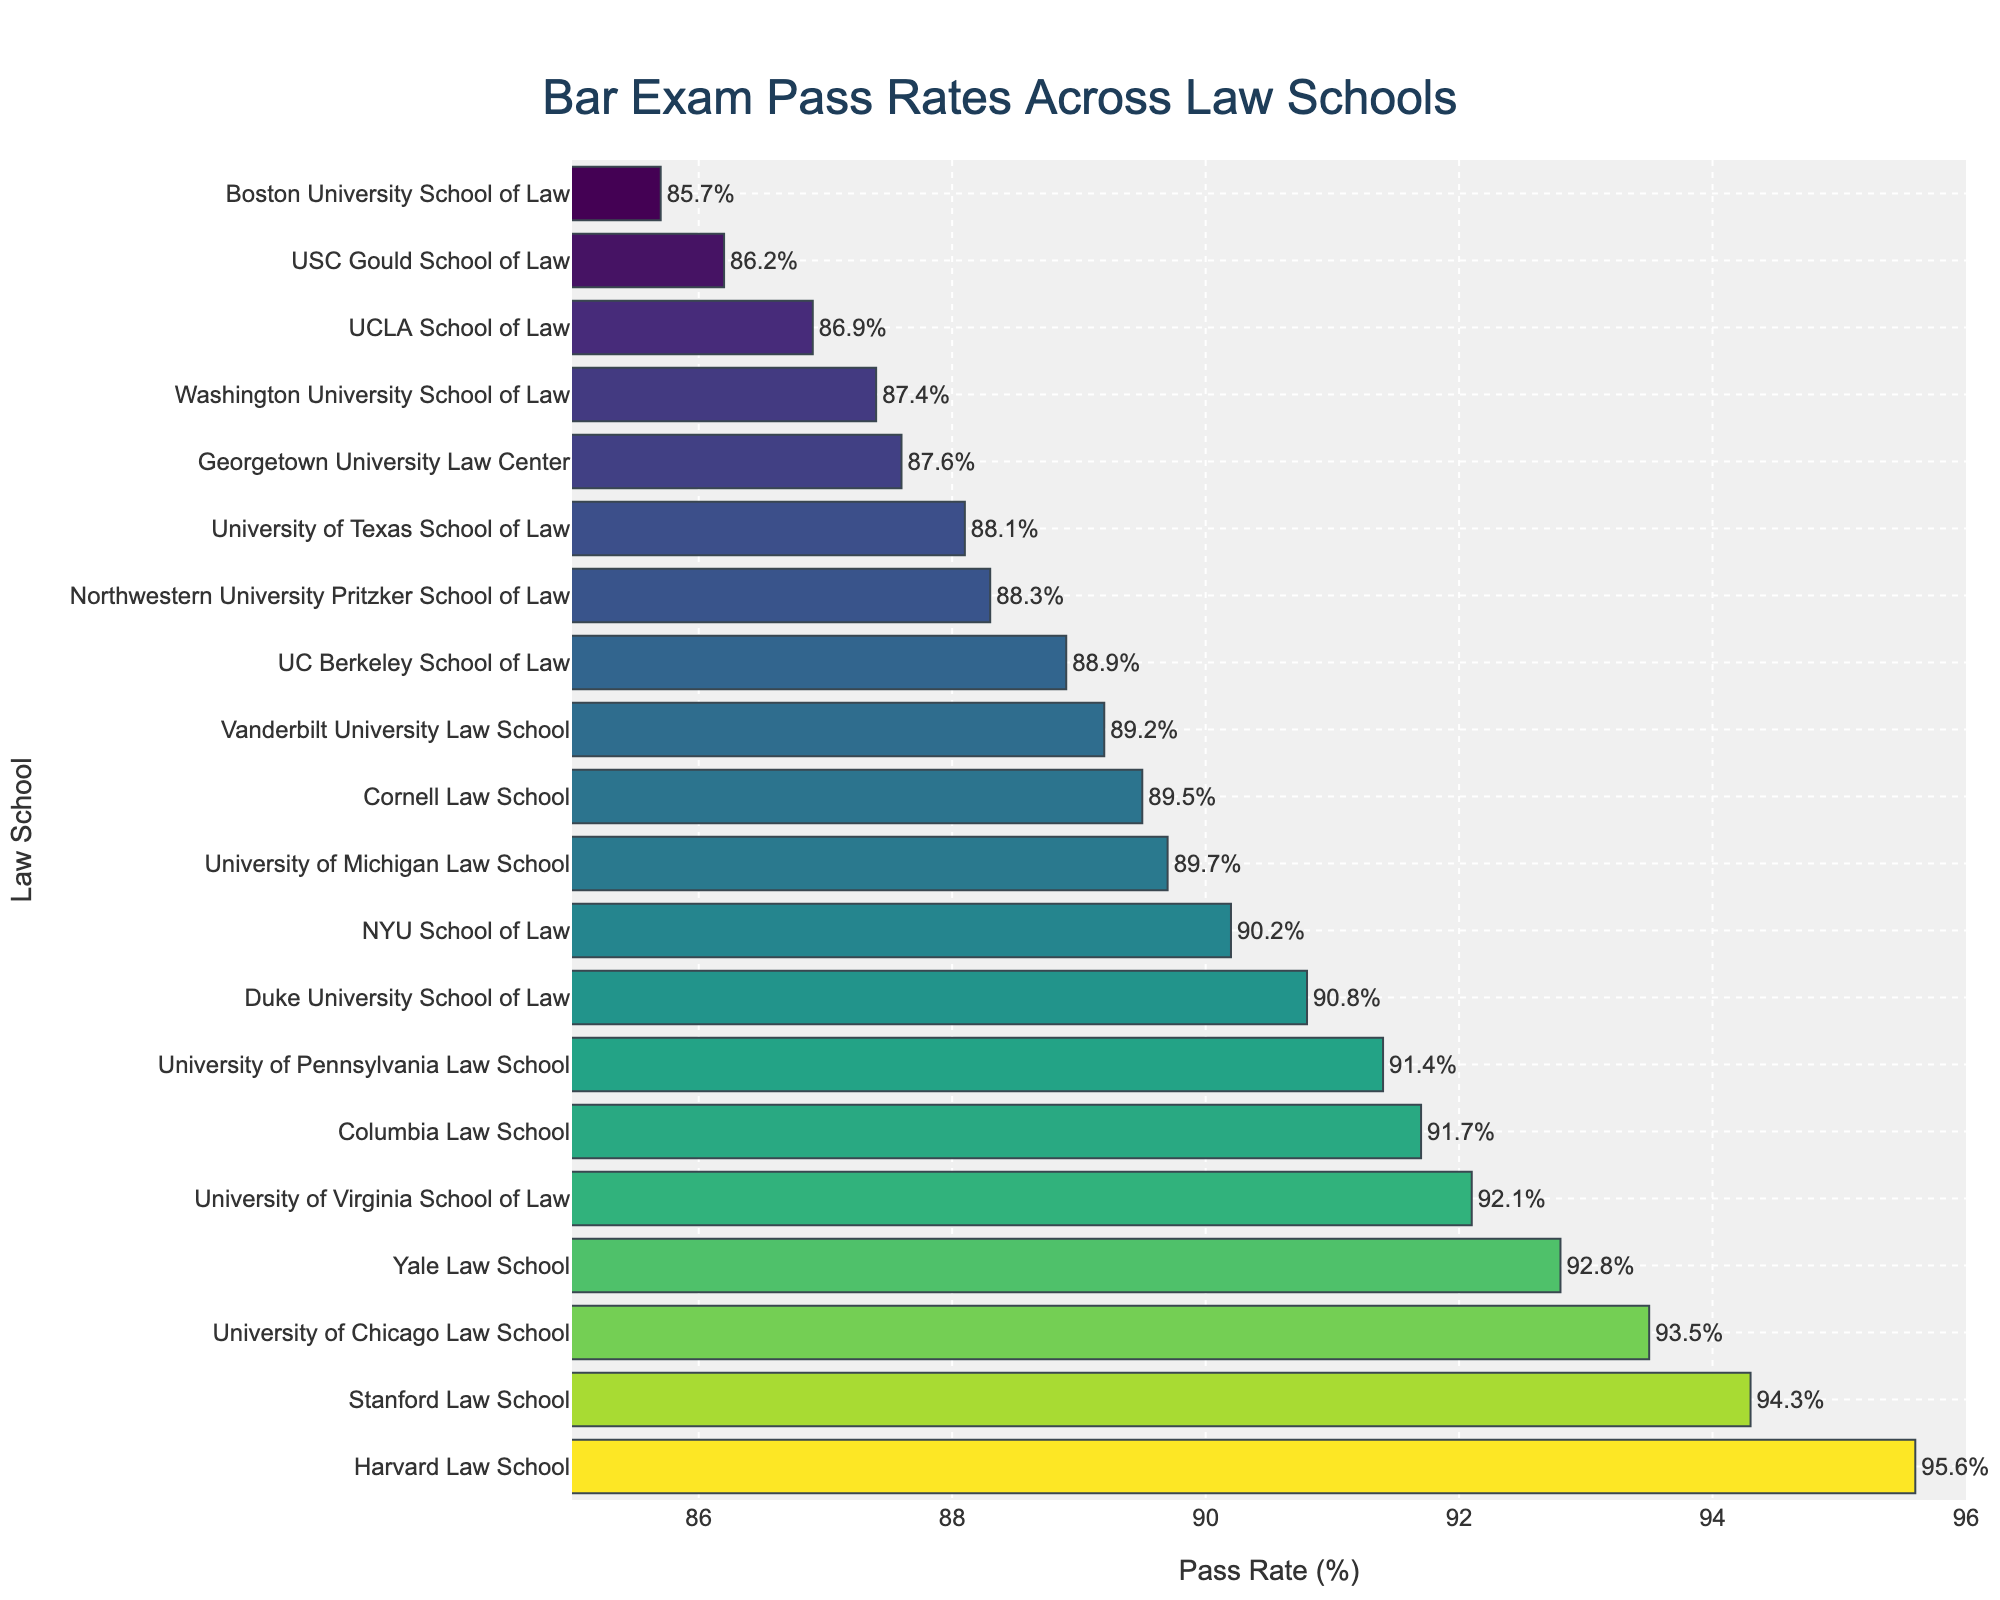Which law school has the highest Bar exam pass rate? By looking at the top position in the chart and the corresponding pass rate, which is the highest value, we see "Harvard Law School" with a pass rate of 95.6%.
Answer: Harvard Law School What is the difference in Bar exam pass rates between Harvard Law School and Columbia Law School? Find the pass rate for both Harvard Law School (95.6%) and Columbia Law School (91.7%), then subtract the latter from the former: 95.6% - 91.7% = 3.9%.
Answer: 3.9% What is the combined pass rate of the top three law schools? Identify the top three law schools by pass rates: Harvard Law School (95.6%), Stanford Law School (94.3%), and Yale Law School (92.8%). Add these rates: 95.6% + 94.3% + 92.8% = 282.7%.
Answer: 282.7% Which law schools have a pass rate less than 90%? Look for bars that are below the 90% line and identify their schools. These are UC Berkeley (88.9%), Northwestern University Pritzker (88.3%), Georgetown University (87.6%), UCLA (86.9%), USC Gould (86.2%), and Boston University School of Law (85.7%).
Answer: UC Berkeley, Northwestern University Pritzker, Georgetown University, UCLA, USC Gould, and Boston University What is the inverted ranking of the schools based on pass rates? Order the schools from the lowest pass rate to the highest by following the bar lengths from shortest to longest. Using that information, we can create the following list: Boston University (85.7%), USC Gould (86.2%), UCLA (86.9%), Georgetown (87.6%), Washington University (87.4%), Texas (88.1%), Northwestern (88.3%), UC Berkeley (88.9%), Vanderbilt (89.2%), Cornell (89.5%), Michigan (89.7%), NYU (90.2%), Duke (90.8%), Penn (91.4%), Columbia (91.7%), Virginia (92.1%), Yale (92.8%), Chicago (93.5%), Stanford (94.3%), Harvard (95.6%).
Answer: Boston University, USC Gould, UCLA, Georgetown, Washington University, Texas, Northwestern, UC Berkeley, Vanderbilt, Cornell, Michigan, NYU, Duke, Penn, Columbia, Virginia, Yale, Chicago, Stanford, Harvard How many schools have a pass rate within 1% of the average pass rate of all listed schools? Calculate the average pass rate of all schools: (95.6+92.8+94.3+91.7+93.5+90.2+88.9+92.1+91.4+89.7+90.8+88.3+89.5+87.6+86.9+88.1+89.2+87.4+86.2+85.7) / 20 = 90.43%. Identify the schools within 1% of this average: NYU (90.2%), Duke (90.8%). Thus, two schools are within 1% of the average.
Answer: 2 Which school is closer to the median pass rate, University of Virginia School of Law or University of Pennsylvania Law School? Sort the rates to find the median. The sorted list is: 85.7, 86.2, 86.9, 87.4, 87.6, 88.1, 88.3, 88.9, 89.2, 89.5, 89.7, 90.2, 90.8, 91.4, 91.7, 92.1, 92.8, 93.5, 94.3, 95.6. The median values are the 10th and 11th values: 89.5 and 89.7, which average to 89.6. University of Virginia has 92.1 and University of Pennsylvania has 91.4; calculate their distances from 89.6:
Answer: University of Pennsylvania 